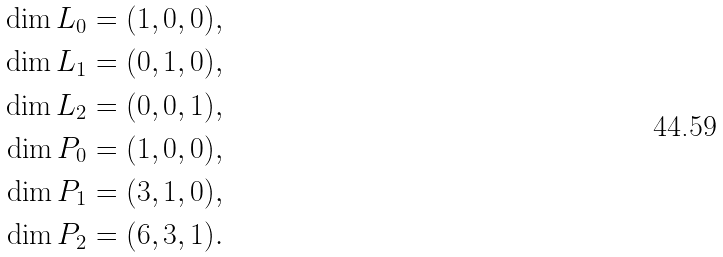<formula> <loc_0><loc_0><loc_500><loc_500>\dim L _ { 0 } & = ( 1 , 0 , 0 ) , \\ \dim L _ { 1 } & = ( 0 , 1 , 0 ) , \\ \dim L _ { 2 } & = ( 0 , 0 , 1 ) , \\ \dim P _ { 0 } & = ( 1 , 0 , 0 ) , \\ \dim P _ { 1 } & = ( 3 , 1 , 0 ) , \\ \dim P _ { 2 } & = ( 6 , 3 , 1 ) .</formula> 